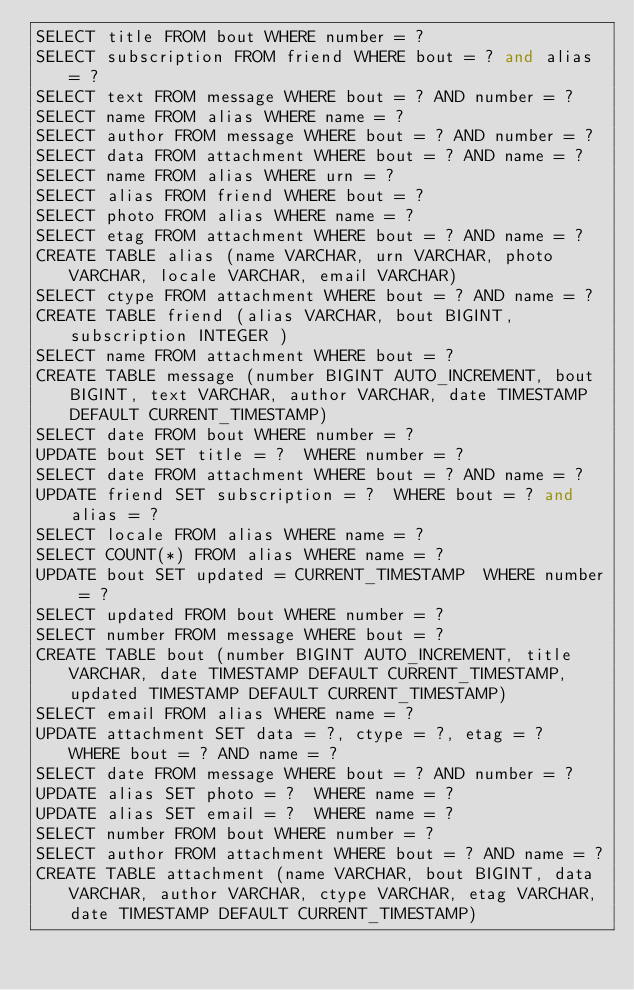Convert code to text. <code><loc_0><loc_0><loc_500><loc_500><_SQL_>SELECT title FROM bout WHERE number = ?
SELECT subscription FROM friend WHERE bout = ? and alias = ?
SELECT text FROM message WHERE bout = ? AND number = ?
SELECT name FROM alias WHERE name = ?
SELECT author FROM message WHERE bout = ? AND number = ?
SELECT data FROM attachment WHERE bout = ? AND name = ?
SELECT name FROM alias WHERE urn = ?
SELECT alias FROM friend WHERE bout = ?
SELECT photo FROM alias WHERE name = ?
SELECT etag FROM attachment WHERE bout = ? AND name = ?
CREATE TABLE alias (name VARCHAR, urn VARCHAR, photo VARCHAR, locale VARCHAR, email VARCHAR)
SELECT ctype FROM attachment WHERE bout = ? AND name = ?
CREATE TABLE friend (alias VARCHAR, bout BIGINT, subscription INTEGER )
SELECT name FROM attachment WHERE bout = ?
CREATE TABLE message (number BIGINT AUTO_INCREMENT, bout BIGINT, text VARCHAR, author VARCHAR, date TIMESTAMP DEFAULT CURRENT_TIMESTAMP)
SELECT date FROM bout WHERE number = ?
UPDATE bout SET title = ?  WHERE number = ?
SELECT date FROM attachment WHERE bout = ? AND name = ?
UPDATE friend SET subscription = ?  WHERE bout = ? and alias = ?
SELECT locale FROM alias WHERE name = ?
SELECT COUNT(*) FROM alias WHERE name = ?
UPDATE bout SET updated = CURRENT_TIMESTAMP  WHERE number = ?
SELECT updated FROM bout WHERE number = ?
SELECT number FROM message WHERE bout = ?
CREATE TABLE bout (number BIGINT AUTO_INCREMENT, title VARCHAR, date TIMESTAMP DEFAULT CURRENT_TIMESTAMP, updated TIMESTAMP DEFAULT CURRENT_TIMESTAMP)
SELECT email FROM alias WHERE name = ?
UPDATE attachment SET data = ?, ctype = ?, etag = ?  WHERE bout = ? AND name = ?
SELECT date FROM message WHERE bout = ? AND number = ?
UPDATE alias SET photo = ?  WHERE name = ?
UPDATE alias SET email = ?  WHERE name = ?
SELECT number FROM bout WHERE number = ?
SELECT author FROM attachment WHERE bout = ? AND name = ?
CREATE TABLE attachment (name VARCHAR, bout BIGINT, data VARCHAR, author VARCHAR, ctype VARCHAR, etag VARCHAR, date TIMESTAMP DEFAULT CURRENT_TIMESTAMP)
</code> 